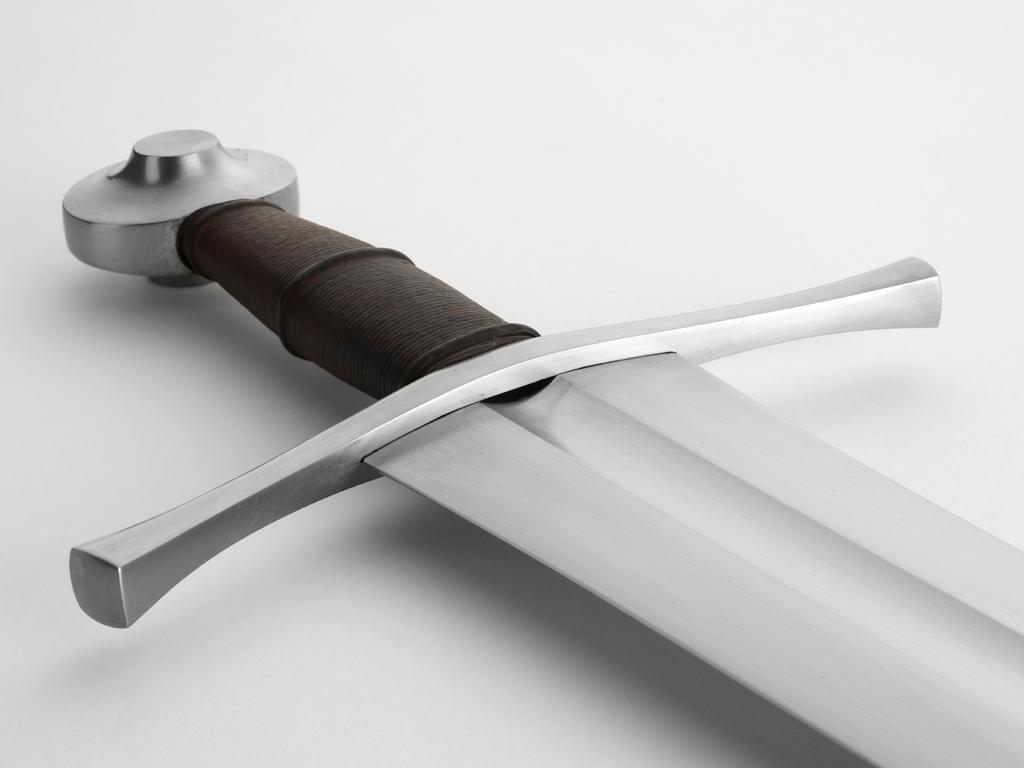What object is the main focus of the image? There is a sword in the image. What is the color of the surface on which the sword is placed? The sword is on a white surface. How does the boy express his hate for the hole in the image? There is no boy or hole present in the image; it only features a sword on a white surface. 